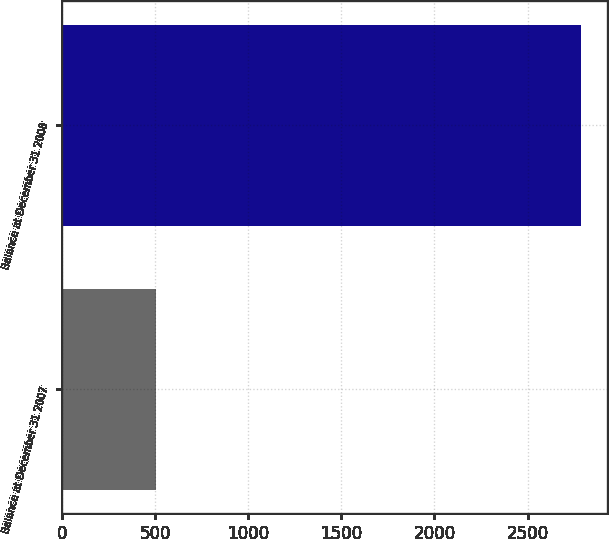<chart> <loc_0><loc_0><loc_500><loc_500><bar_chart><fcel>Balance at December 31 2007<fcel>Balance at December 31 2008<nl><fcel>503<fcel>2786<nl></chart> 